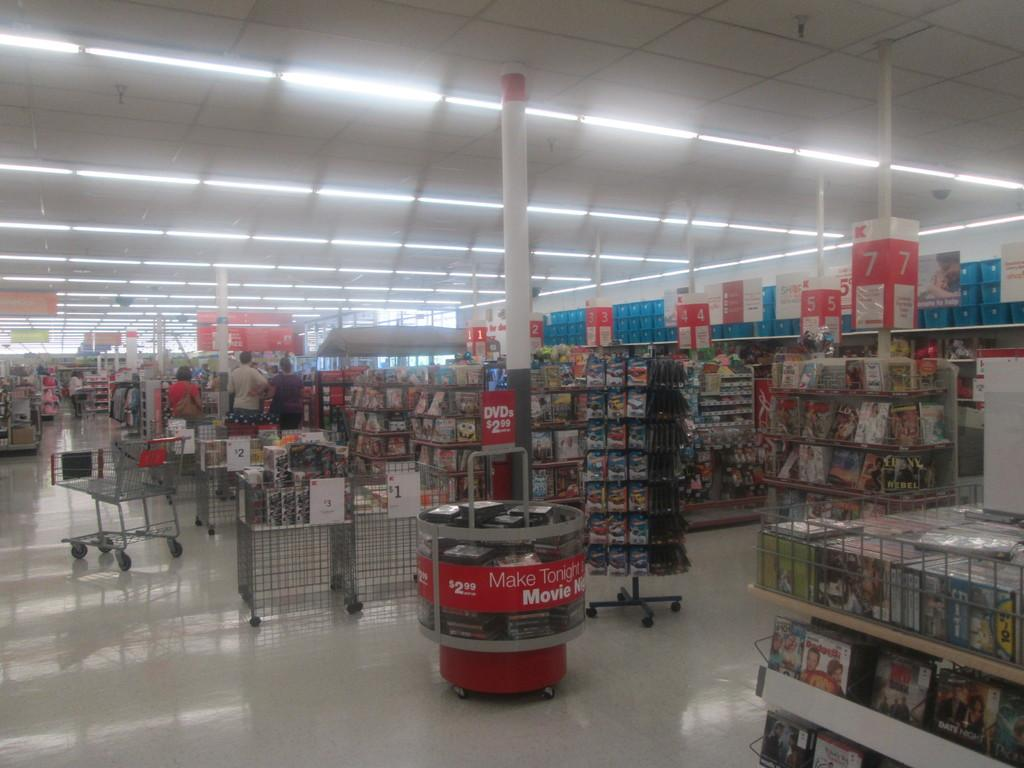<image>
Render a clear and concise summary of the photo. a retail store interior that has a display of movies for sale 